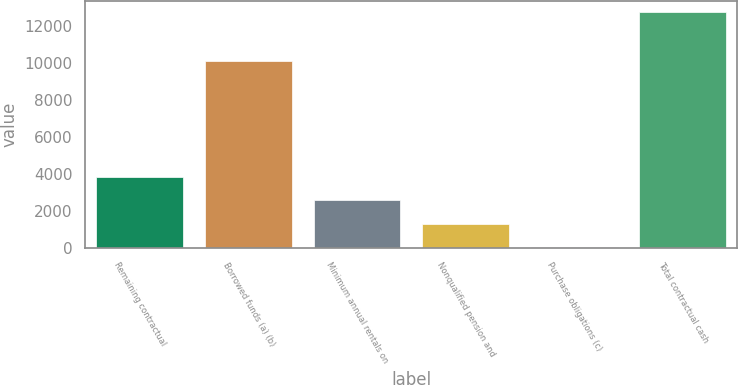<chart> <loc_0><loc_0><loc_500><loc_500><bar_chart><fcel>Remaining contractual<fcel>Borrowed funds (a) (b)<fcel>Minimum annual rentals on<fcel>Nonqualified pension and<fcel>Purchase obligations (c)<fcel>Total contractual cash<nl><fcel>3840.7<fcel>10143<fcel>2565.8<fcel>1290.9<fcel>16<fcel>12765<nl></chart> 